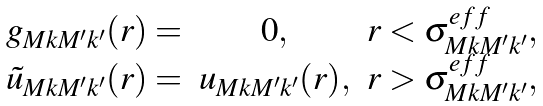Convert formula to latex. <formula><loc_0><loc_0><loc_500><loc_500>\begin{array} { c c c } g _ { M k M ^ { \prime } k ^ { \prime } } ( r ) = & 0 , & r < \sigma _ { M k M ^ { \prime } k ^ { \prime } } ^ { e f f } , \\ { \tilde { u } } _ { M k M ^ { \prime } k ^ { \prime } } ( r ) = & u _ { M k M ^ { \prime } k ^ { \prime } } ( r ) , & r > \sigma _ { M k M ^ { \prime } k ^ { \prime } } ^ { e f f } , \end{array}</formula> 